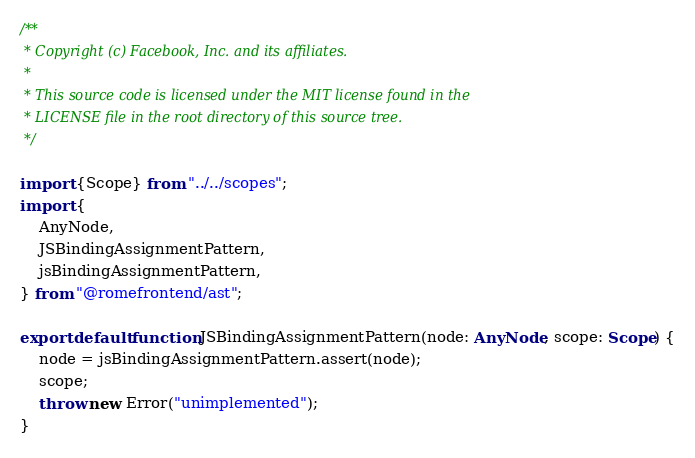<code> <loc_0><loc_0><loc_500><loc_500><_TypeScript_>/**
 * Copyright (c) Facebook, Inc. and its affiliates.
 *
 * This source code is licensed under the MIT license found in the
 * LICENSE file in the root directory of this source tree.
 */

import {Scope} from "../../scopes";
import {
	AnyNode,
	JSBindingAssignmentPattern,
	jsBindingAssignmentPattern,
} from "@romefrontend/ast";

export default function JSBindingAssignmentPattern(node: AnyNode, scope: Scope) {
	node = jsBindingAssignmentPattern.assert(node);
	scope;
	throw new Error("unimplemented");
}
</code> 